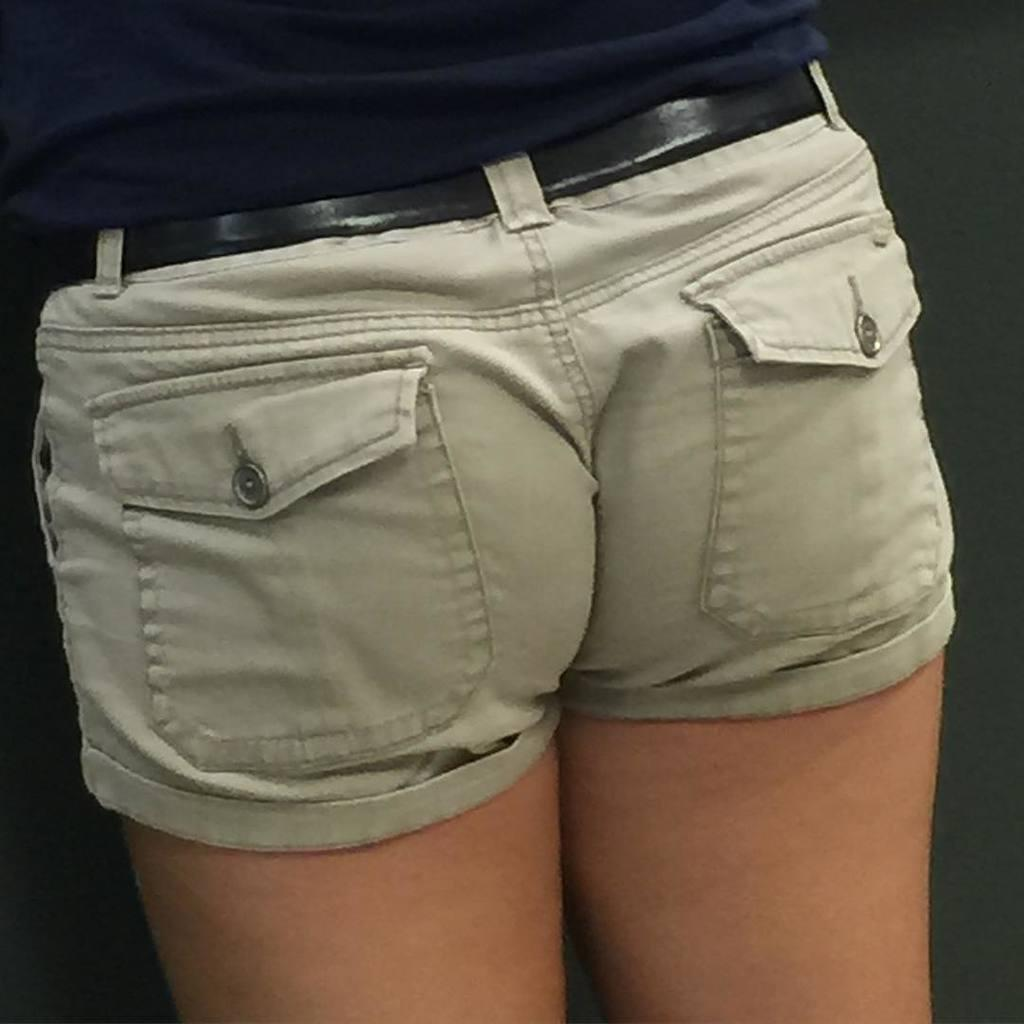Who is present in the image? There is a person in the image. What is the person wearing? The person is wearing a dark blue t-shirt. What is the person's posture in the image? The person is standing. What can be seen behind the person in the image? There is a wall in the background of the image. Reasoning: Let' Let's think step by step in order to produce the conversation. We start by identifying the main subject in the image, which is the person. Then, we describe the person's clothing and posture. Finally, we mention the background of the image, which is a wall. Each question is designed to elicit a specific detail about the image that is known from the provided facts. Absurd Question/Answer: What is the person talking about in the image? There is no indication of a conversation or any talking in the image. What type of ground is visible in the image? There is no ground visible in the image; it appears to be an indoor setting with a wall in the background. 